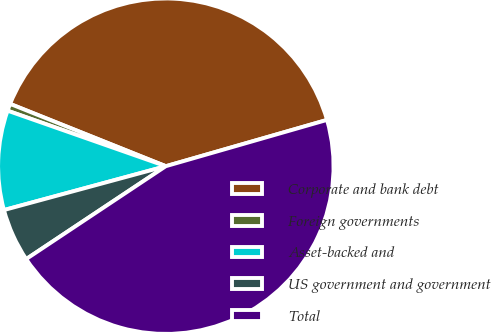Convert chart. <chart><loc_0><loc_0><loc_500><loc_500><pie_chart><fcel>Corporate and bank debt<fcel>Foreign governments<fcel>Asset-backed and<fcel>US government and government<fcel>Total<nl><fcel>39.49%<fcel>0.69%<fcel>9.58%<fcel>5.13%<fcel>45.11%<nl></chart> 